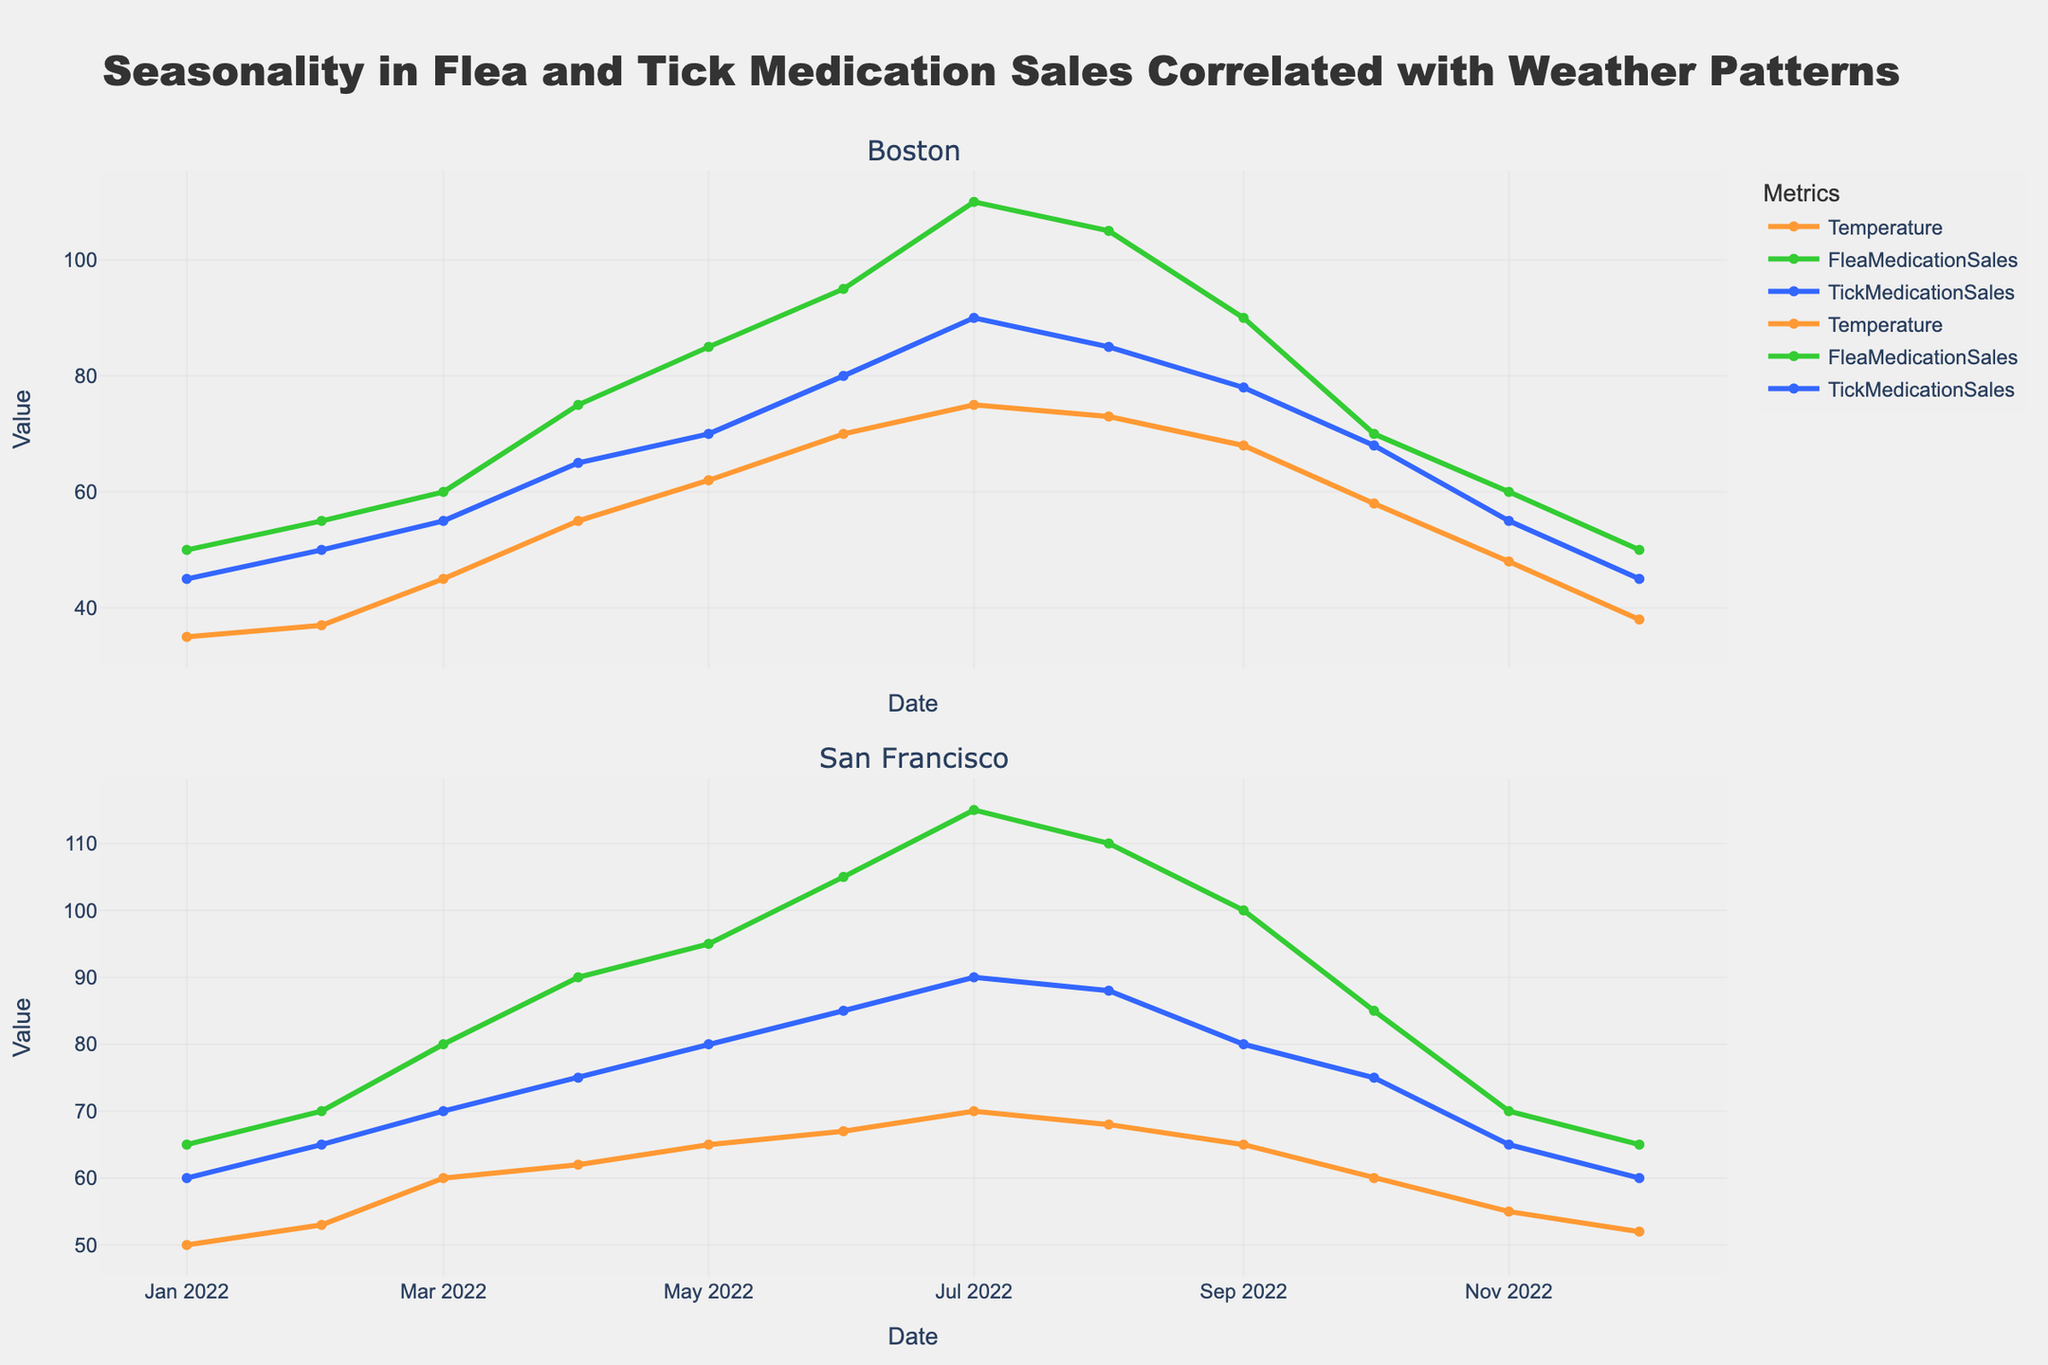What's the title of the plot? The title of the plot is prominently displayed at the top and reads "Seasonality in Flea and Tick Medication Sales Correlated with Weather Patterns."
Answer: Seasonality in Flea and Tick Medication Sales Correlated with Weather Patterns Which metric uses the orange color for its line? By examining the legend and the lines in the plot, we see that the orange line represents the "Temperature" metric.
Answer: Temperature How does the sales of Flea Medication in Boston change from January to July? From January to July in Boston, the sales of Flea Medication increase from 50 to 110, showing a steady monthly increase.
Answer: Increase from 50 to 110 What is the temperature in San Francisco in June? The value of the temperature in June is marked by the intersection of the orange line with the vertical line at June. According to the plot, the temperature is 67°F.
Answer: 67°F Which city shows higher sales of Tick Medication in August? By comparing the blue lines in August for both cities, we can see that Boston has 85 sales while San Francisco has 88 sales. San Francisco has higher sales.
Answer: San Francisco In which month is the temperature highest in Boston? By inspecting the orange line for Boston, the highest point occurs in July, where the temperature is 75°F.
Answer: July How do the Flea Medication and Tick Medication sales compare in San Francisco in March? Examining the plot for March for San Francisco, Flea Medication sales are 80 and Tick Medication sales are 70. Flea Medication sales are higher.
Answer: Flea Medication sales are higher What's the average Flea Medication sales in Boston for the first quarter (Jan, Feb, Mar)? To find the average, sum the sales for January (50), February (55), and March (60) which equals 165, and divide by 3, resulting in 55.
Answer: 55 Do Flea Medication sales in Boston and San Francisco follow the same trend throughout the year? Observing the green lines for both cities, both Flea Medication sales display an increasing trend from January to July, then decreasing afterward, indicating a similar seasonal trend.
Answer: Yes Between which months is there the largest increase in Tick Medication sales in San Francisco? Identifying the largest monthly increase, the blue lines indicate the largest increase is between May (80) and June (85), totaling a 25-unit increase.
Answer: May to June 